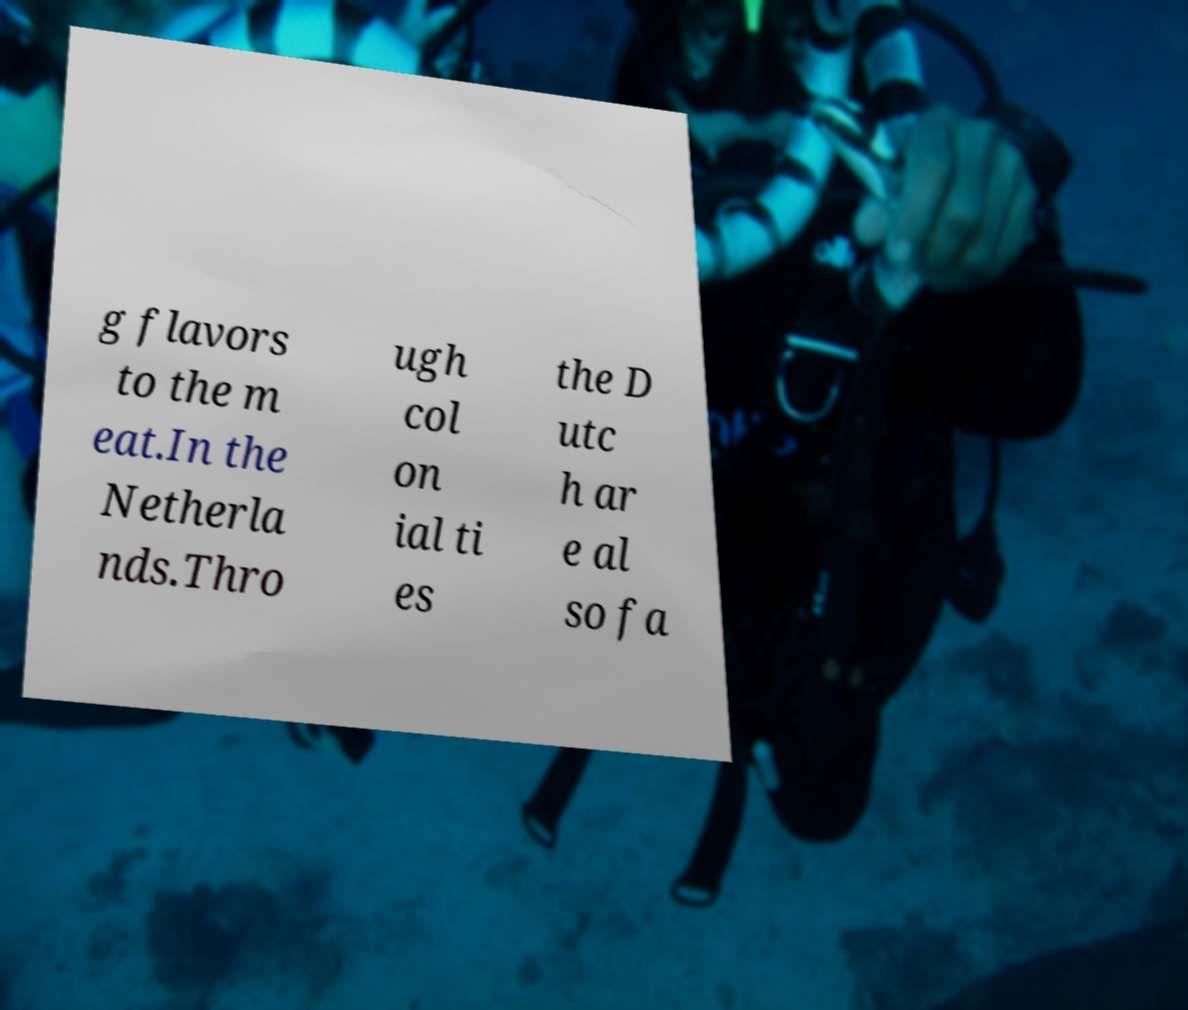I need the written content from this picture converted into text. Can you do that? g flavors to the m eat.In the Netherla nds.Thro ugh col on ial ti es the D utc h ar e al so fa 